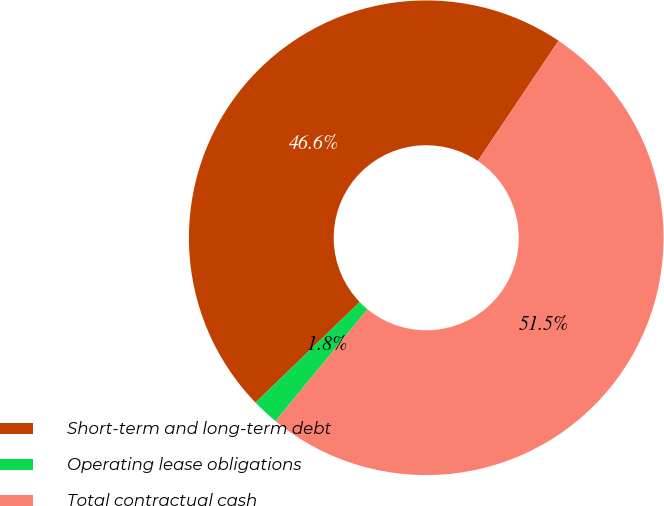Convert chart. <chart><loc_0><loc_0><loc_500><loc_500><pie_chart><fcel>Short-term and long-term debt<fcel>Operating lease obligations<fcel>Total contractual cash<nl><fcel>46.64%<fcel>1.83%<fcel>51.54%<nl></chart> 